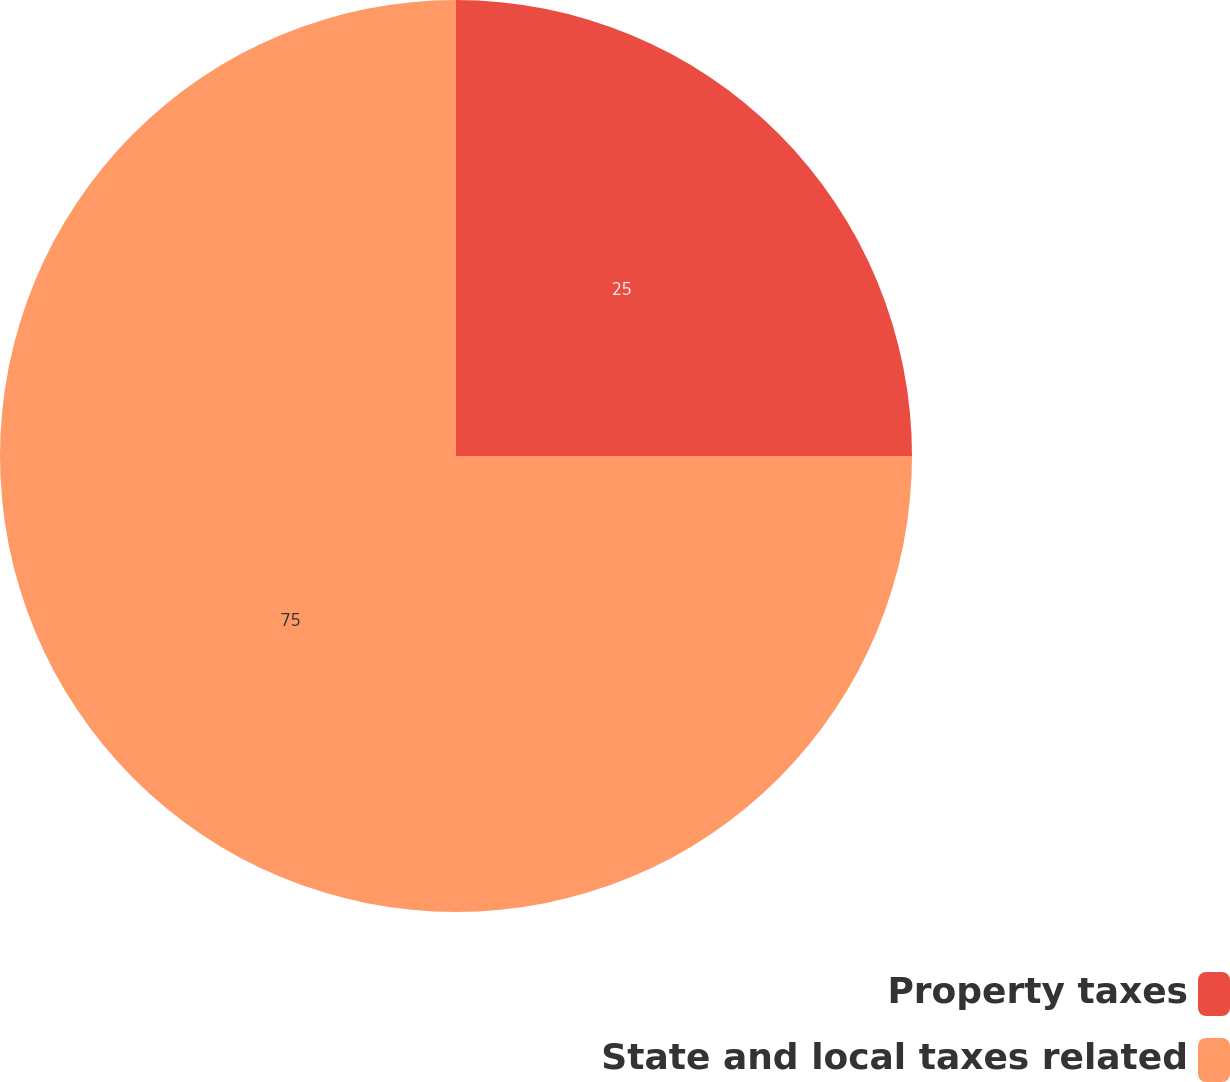Convert chart. <chart><loc_0><loc_0><loc_500><loc_500><pie_chart><fcel>Property taxes<fcel>State and local taxes related<nl><fcel>25.0%<fcel>75.0%<nl></chart> 